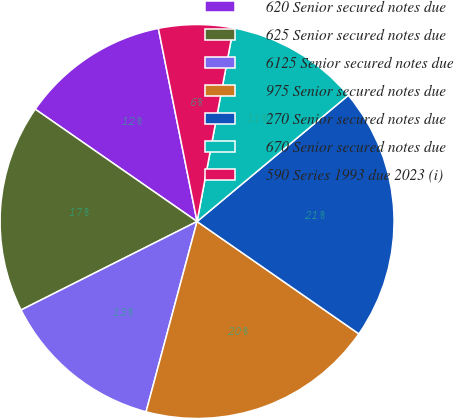Convert chart. <chart><loc_0><loc_0><loc_500><loc_500><pie_chart><fcel>620 Senior secured notes due<fcel>625 Senior secured notes due<fcel>6125 Senior secured notes due<fcel>975 Senior secured notes due<fcel>270 Senior secured notes due<fcel>670 Senior secured notes due<fcel>590 Series 1993 due 2023 (i)<nl><fcel>12.2%<fcel>17.07%<fcel>13.42%<fcel>19.51%<fcel>20.73%<fcel>10.98%<fcel>6.1%<nl></chart> 